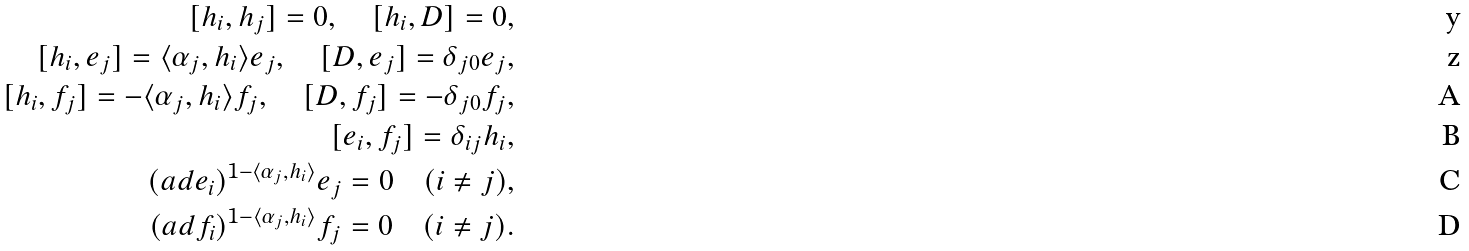<formula> <loc_0><loc_0><loc_500><loc_500>[ h _ { i } , h _ { j } ] = 0 , \quad [ h _ { i } , D ] = 0 , \\ [ h _ { i } , e _ { j } ] = \langle \alpha _ { j } , h _ { i } \rangle e _ { j } , \quad [ D , e _ { j } ] = \delta _ { j 0 } e _ { j } , \\ [ h _ { i } , f _ { j } ] = - \langle \alpha _ { j } , h _ { i } \rangle f _ { j } , \quad [ D , f _ { j } ] = - \delta _ { j 0 } f _ { j } , \\ [ e _ { i } , f _ { j } ] = \delta _ { i j } h _ { i } , \\ ( { a d } e _ { i } ) ^ { 1 - \langle \alpha _ { j } , h _ { i } \rangle } e _ { j } = 0 \quad ( i \neq j ) , \\ ( { a d } f _ { i } ) ^ { 1 - \langle \alpha _ { j } , h _ { i } \rangle } f _ { j } = 0 \quad ( i \neq j ) .</formula> 